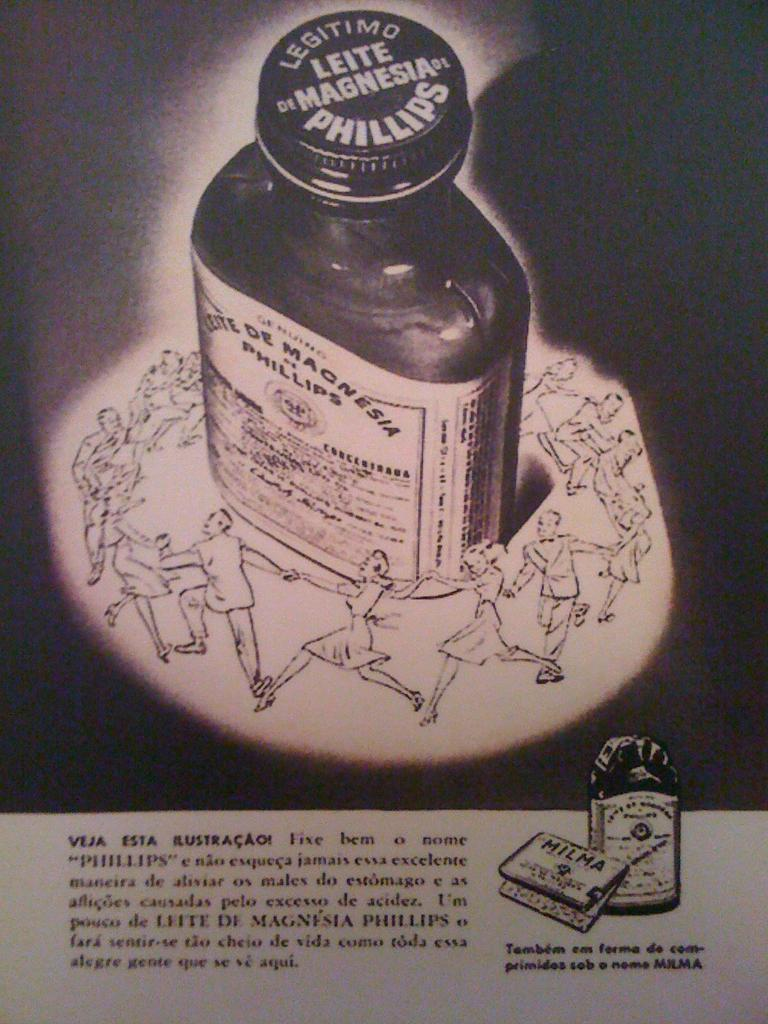Provide a one-sentence caption for the provided image. An advertisement for Legitimo Leite de Magnesia by Phillips. 